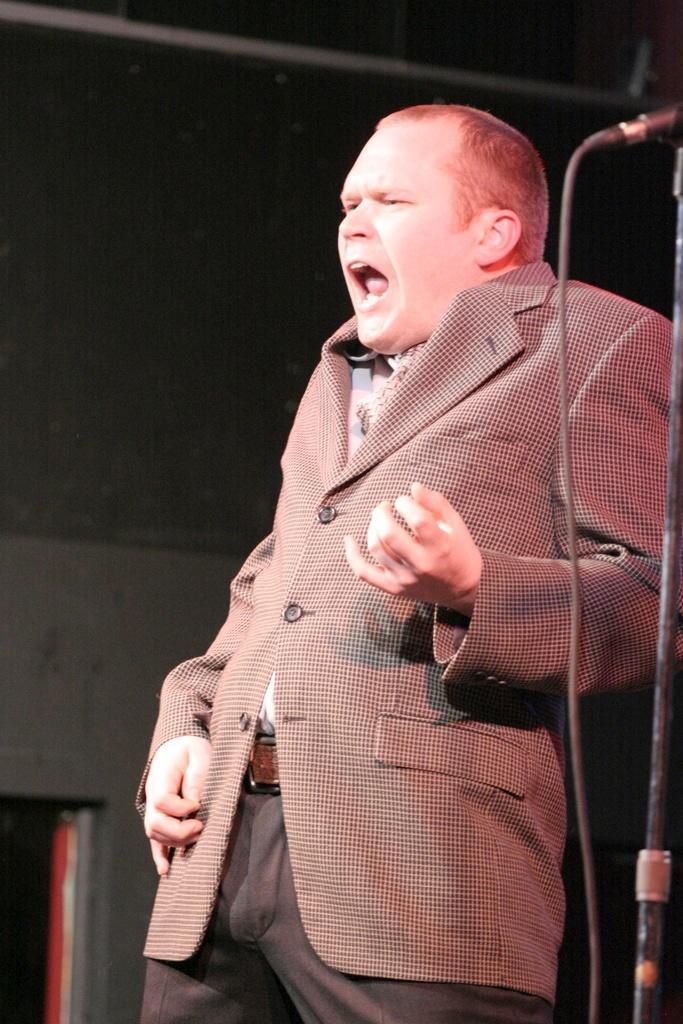How would you summarize this image in a sentence or two? In this picture we can see a man is standing, in the background there is a wall, on the right side we can see a microphone. 